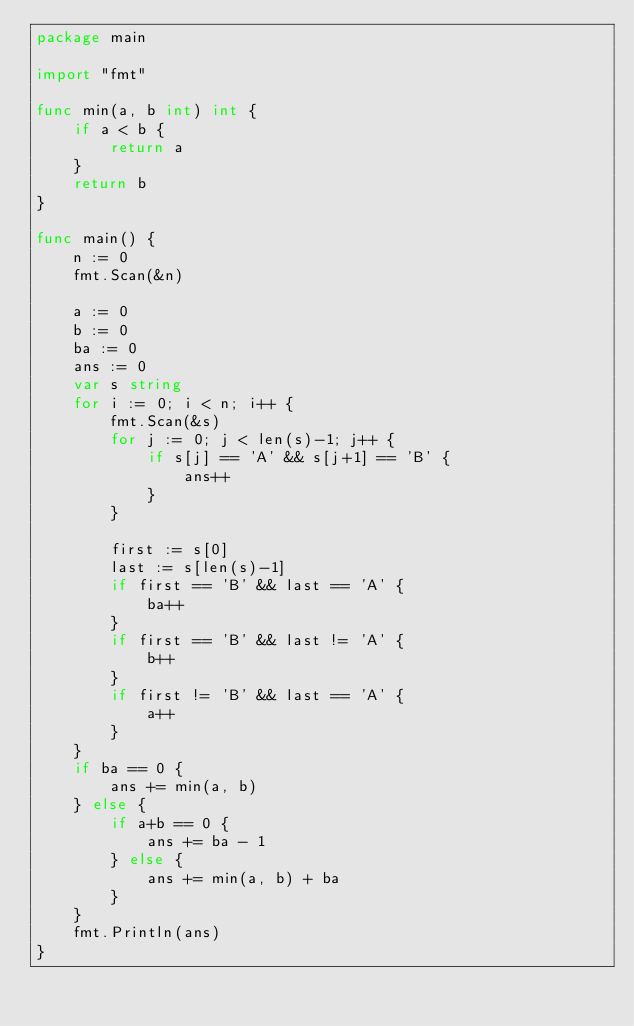<code> <loc_0><loc_0><loc_500><loc_500><_Go_>package main

import "fmt"

func min(a, b int) int {
	if a < b {
		return a
	}
	return b
}

func main() {
	n := 0
	fmt.Scan(&n)

	a := 0
	b := 0
	ba := 0
	ans := 0
	var s string
	for i := 0; i < n; i++ {
		fmt.Scan(&s)
		for j := 0; j < len(s)-1; j++ {
			if s[j] == 'A' && s[j+1] == 'B' {
				ans++
			}
		}

		first := s[0]
		last := s[len(s)-1]
		if first == 'B' && last == 'A' {
			ba++
		}
		if first == 'B' && last != 'A' {
			b++
		}
		if first != 'B' && last == 'A' {
			a++
		}
	}
	if ba == 0 {
		ans += min(a, b)
	} else {
		if a+b == 0 {
			ans += ba - 1
		} else {
			ans += min(a, b) + ba
		}
	}
	fmt.Println(ans)
}
</code> 